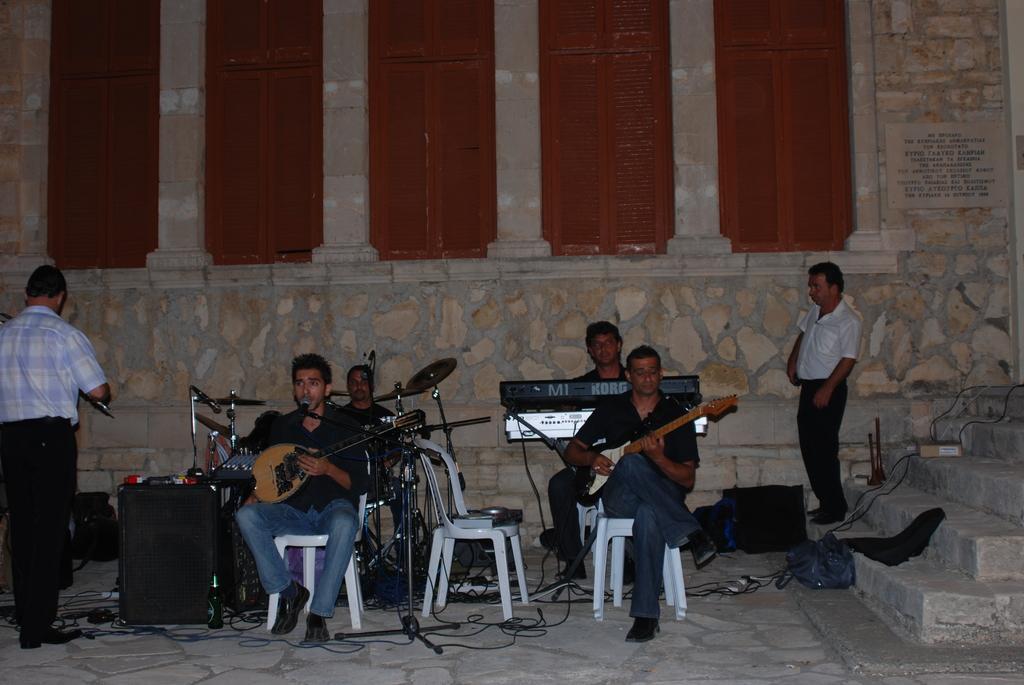Can you describe this image briefly? In this picture, we see two men sitting on chair are holding guitar in their hands and playing it. Behind them, man in black shirt is playing drums and beside him, we see man playing keyboard and on the right bottom of the picture, we see staircase and behind that, we see wall which is made up of stone. 